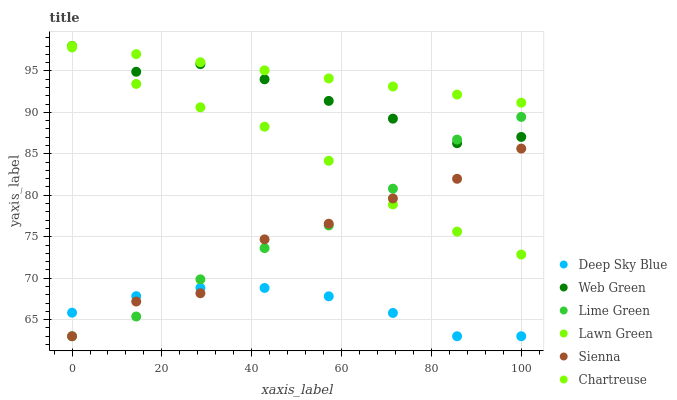Does Deep Sky Blue have the minimum area under the curve?
Answer yes or no. Yes. Does Chartreuse have the maximum area under the curve?
Answer yes or no. Yes. Does Web Green have the minimum area under the curve?
Answer yes or no. No. Does Web Green have the maximum area under the curve?
Answer yes or no. No. Is Chartreuse the smoothest?
Answer yes or no. Yes. Is Sienna the roughest?
Answer yes or no. Yes. Is Web Green the smoothest?
Answer yes or no. No. Is Web Green the roughest?
Answer yes or no. No. Does Sienna have the lowest value?
Answer yes or no. Yes. Does Web Green have the lowest value?
Answer yes or no. No. Does Chartreuse have the highest value?
Answer yes or no. Yes. Does Sienna have the highest value?
Answer yes or no. No. Is Deep Sky Blue less than Chartreuse?
Answer yes or no. Yes. Is Web Green greater than Lawn Green?
Answer yes or no. Yes. Does Sienna intersect Deep Sky Blue?
Answer yes or no. Yes. Is Sienna less than Deep Sky Blue?
Answer yes or no. No. Is Sienna greater than Deep Sky Blue?
Answer yes or no. No. Does Deep Sky Blue intersect Chartreuse?
Answer yes or no. No. 